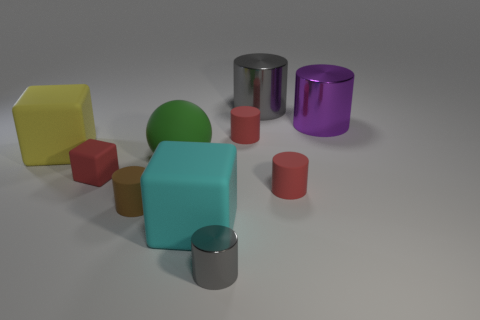Which objects in this image could fit inside each other based on their sizes? Observing the relative sizes, the smaller red cubes could fit inside the larger cylinders, and potentially, those cylinders could fit into the larger purple or silver cylinders if their diameters are large enough. 